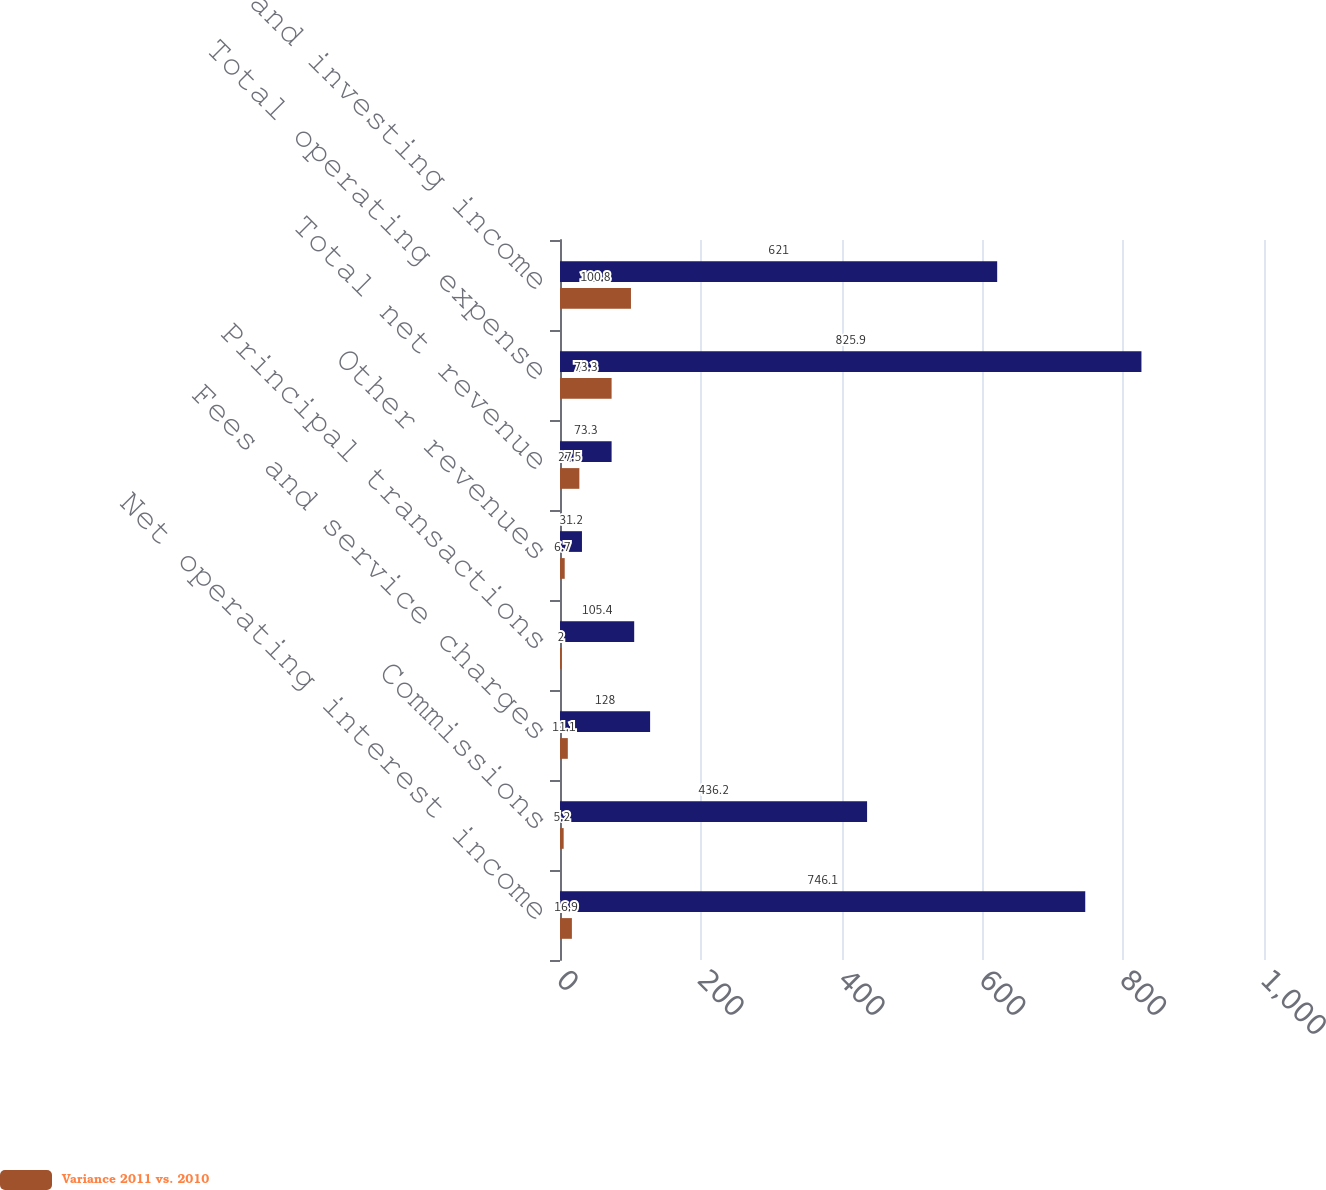Convert chart to OTSL. <chart><loc_0><loc_0><loc_500><loc_500><stacked_bar_chart><ecel><fcel>Net operating interest income<fcel>Commissions<fcel>Fees and service charges<fcel>Principal transactions<fcel>Other revenues<fcel>Total net revenue<fcel>Total operating expense<fcel>Trading and investing income<nl><fcel>nan<fcel>746.1<fcel>436.2<fcel>128<fcel>105.4<fcel>31.2<fcel>73.3<fcel>825.9<fcel>621<nl><fcel>Variance 2011 vs. 2010<fcel>16.9<fcel>5.2<fcel>11.1<fcel>2<fcel>6.7<fcel>27.5<fcel>73.3<fcel>100.8<nl></chart> 